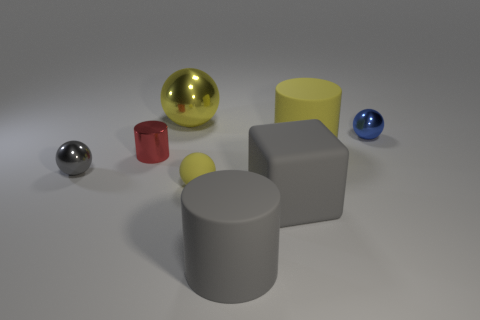Subtract 1 cylinders. How many cylinders are left? 2 Subtract all large matte cylinders. How many cylinders are left? 1 Add 1 shiny cylinders. How many objects exist? 9 Subtract all green balls. Subtract all purple cubes. How many balls are left? 4 Subtract all blocks. How many objects are left? 7 Subtract all large gray matte things. Subtract all cylinders. How many objects are left? 3 Add 1 matte spheres. How many matte spheres are left? 2 Add 2 big green metallic cylinders. How many big green metallic cylinders exist? 2 Subtract 0 purple blocks. How many objects are left? 8 